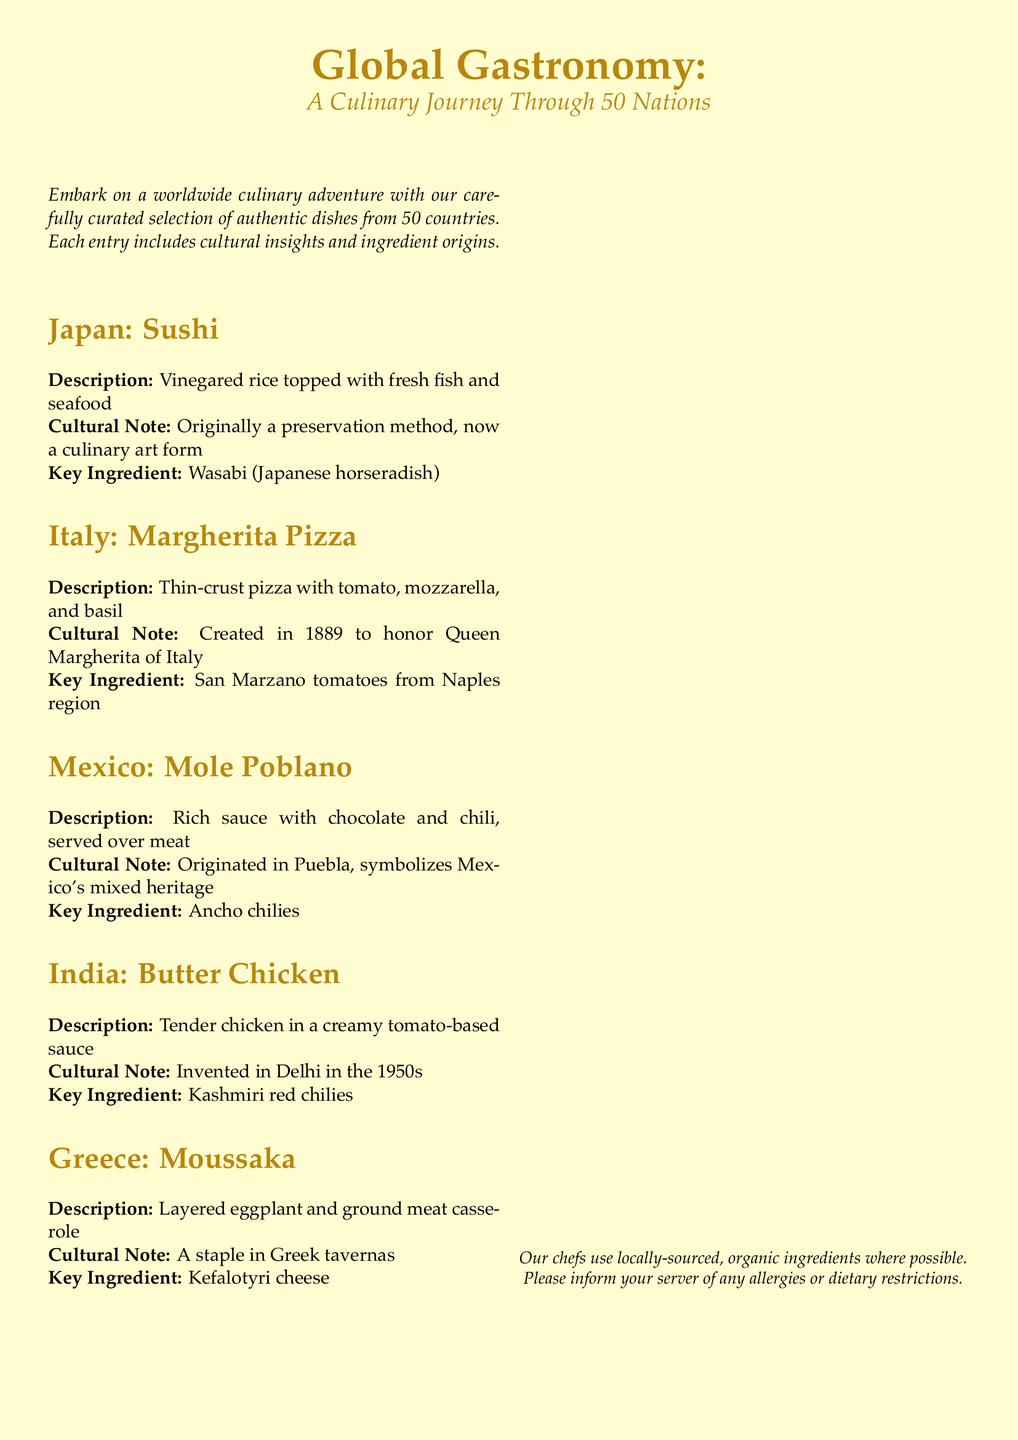What is the title of the menu? The title, prominently displayed at the top of the document, is "Global Gastronomy: A Culinary Journey Through 50 Nations."
Answer: Global Gastronomy: A Culinary Journey Through 50 Nations How many countries are featured in the menu? The menu includes authentic dishes from 50 countries, as stated in the introductory text.
Answer: 50 What dish is associated with Japan? The menu lists "Sushi" as the dish from Japan, specified in the section headings.
Answer: Sushi What is a key ingredient in Margherita Pizza? The menu mentions "San Marzano tomatoes from Naples region" as the key ingredient for Margherita Pizza.
Answer: San Marzano tomatoes When was Margherita Pizza created? The menu states that Margherita Pizza was created in 1889 to honor Queen Margherita of Italy.
Answer: 1889 What cultural note is given for Mole Poblano? The cultural note for Mole Poblano highlights its origin in Puebla and its representation of Mexico's mixed heritage.
Answer: Originated in Puebla, symbolizes Mexico's mixed heritage Which key ingredient is used in Butter Chicken? The key ingredient listed for Butter Chicken is "Kashmiri red chilies," as noted in the document.
Answer: Kashmiri red chilies What type of dish is Moussaka? The description of Moussaka indicates it is a "layered eggplant and ground meat casserole."
Answer: Layered eggplant and ground meat casserole Where does the document suggest to inform about allergies? The document advises to inform your server of any allergies or dietary restrictions, found in the footnote text.
Answer: Your server 